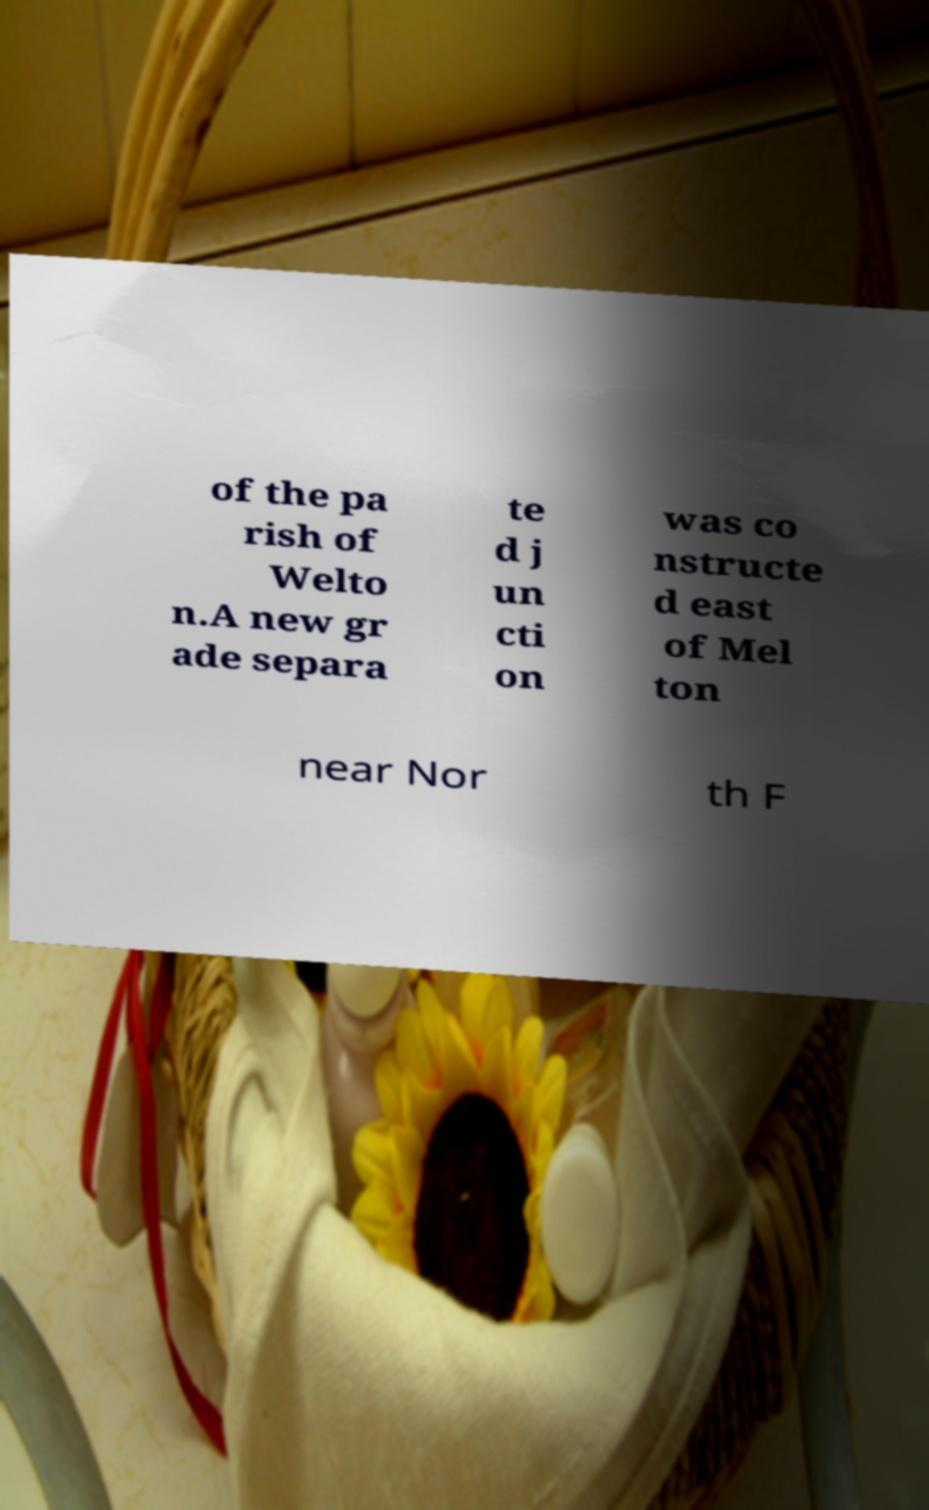For documentation purposes, I need the text within this image transcribed. Could you provide that? of the pa rish of Welto n.A new gr ade separa te d j un cti on was co nstructe d east of Mel ton near Nor th F 